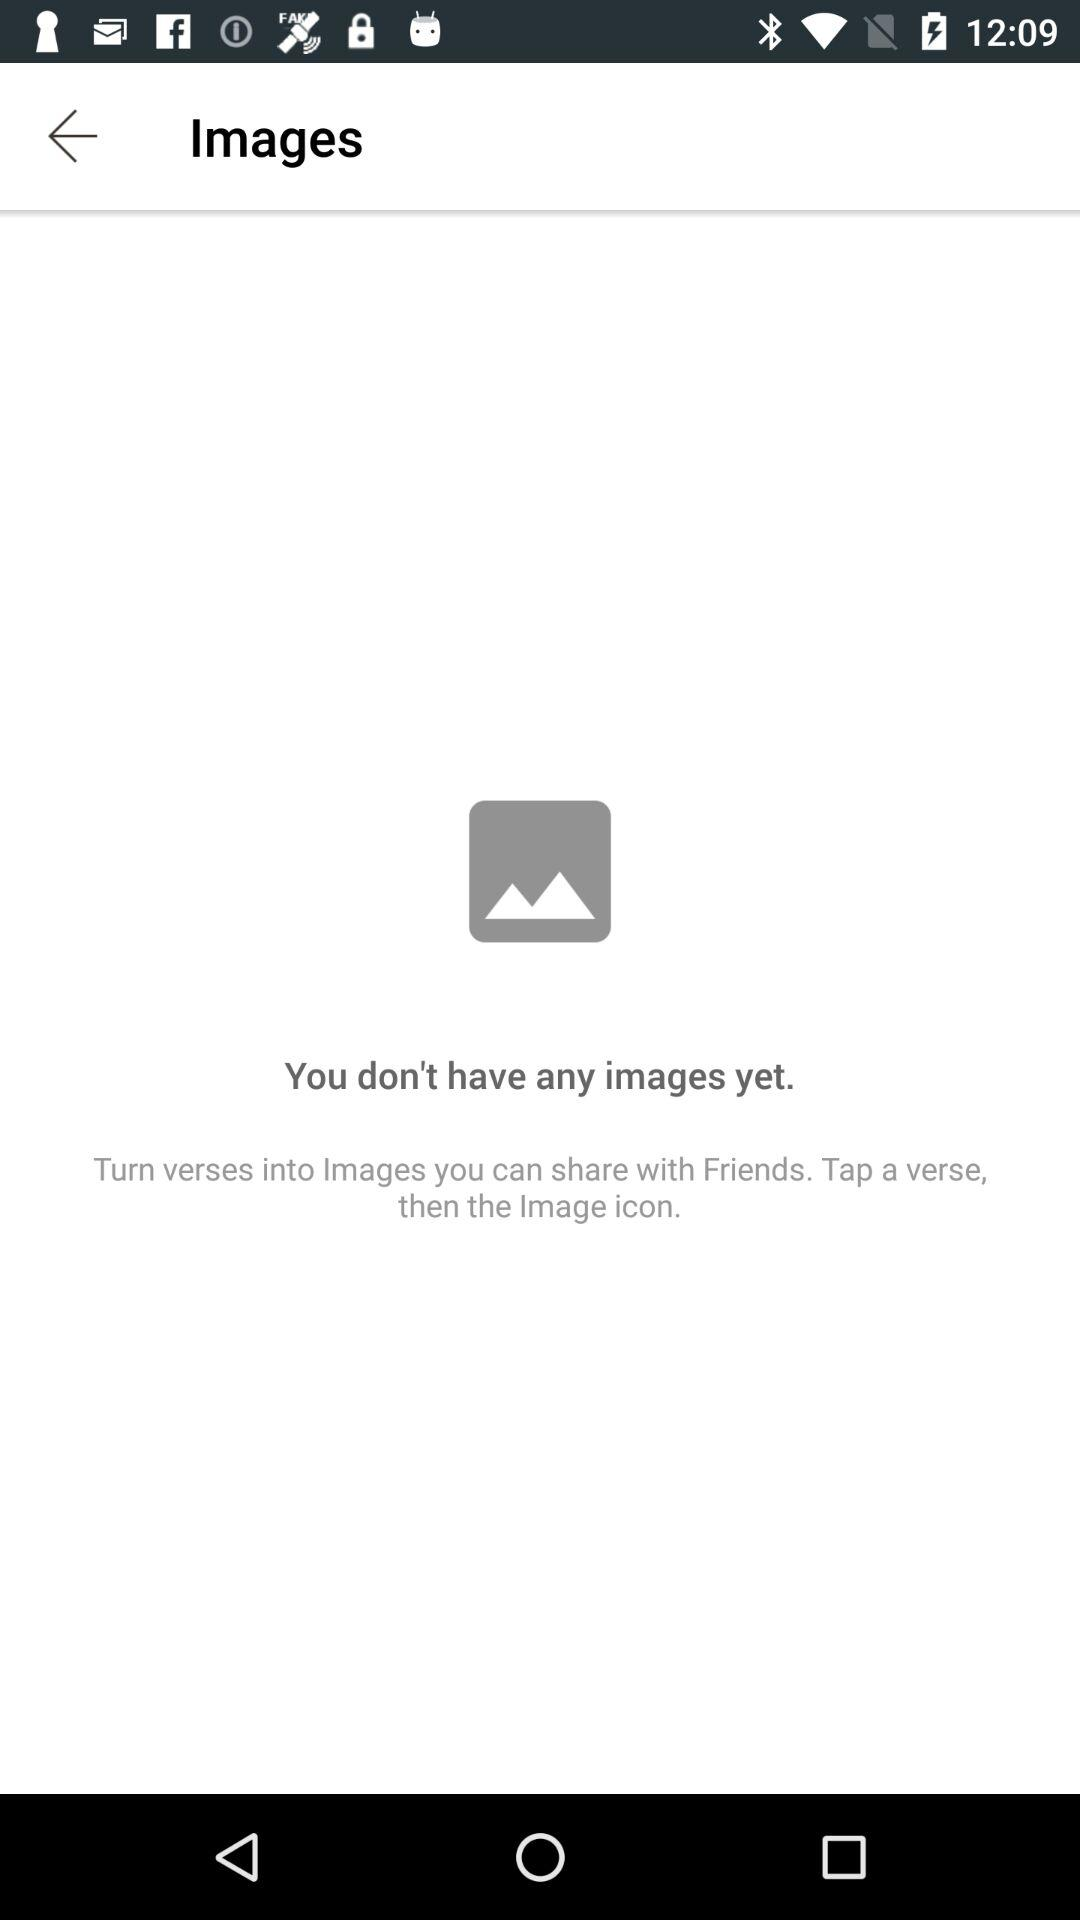Are there any images present in the folder? There are no images present in the folder. 